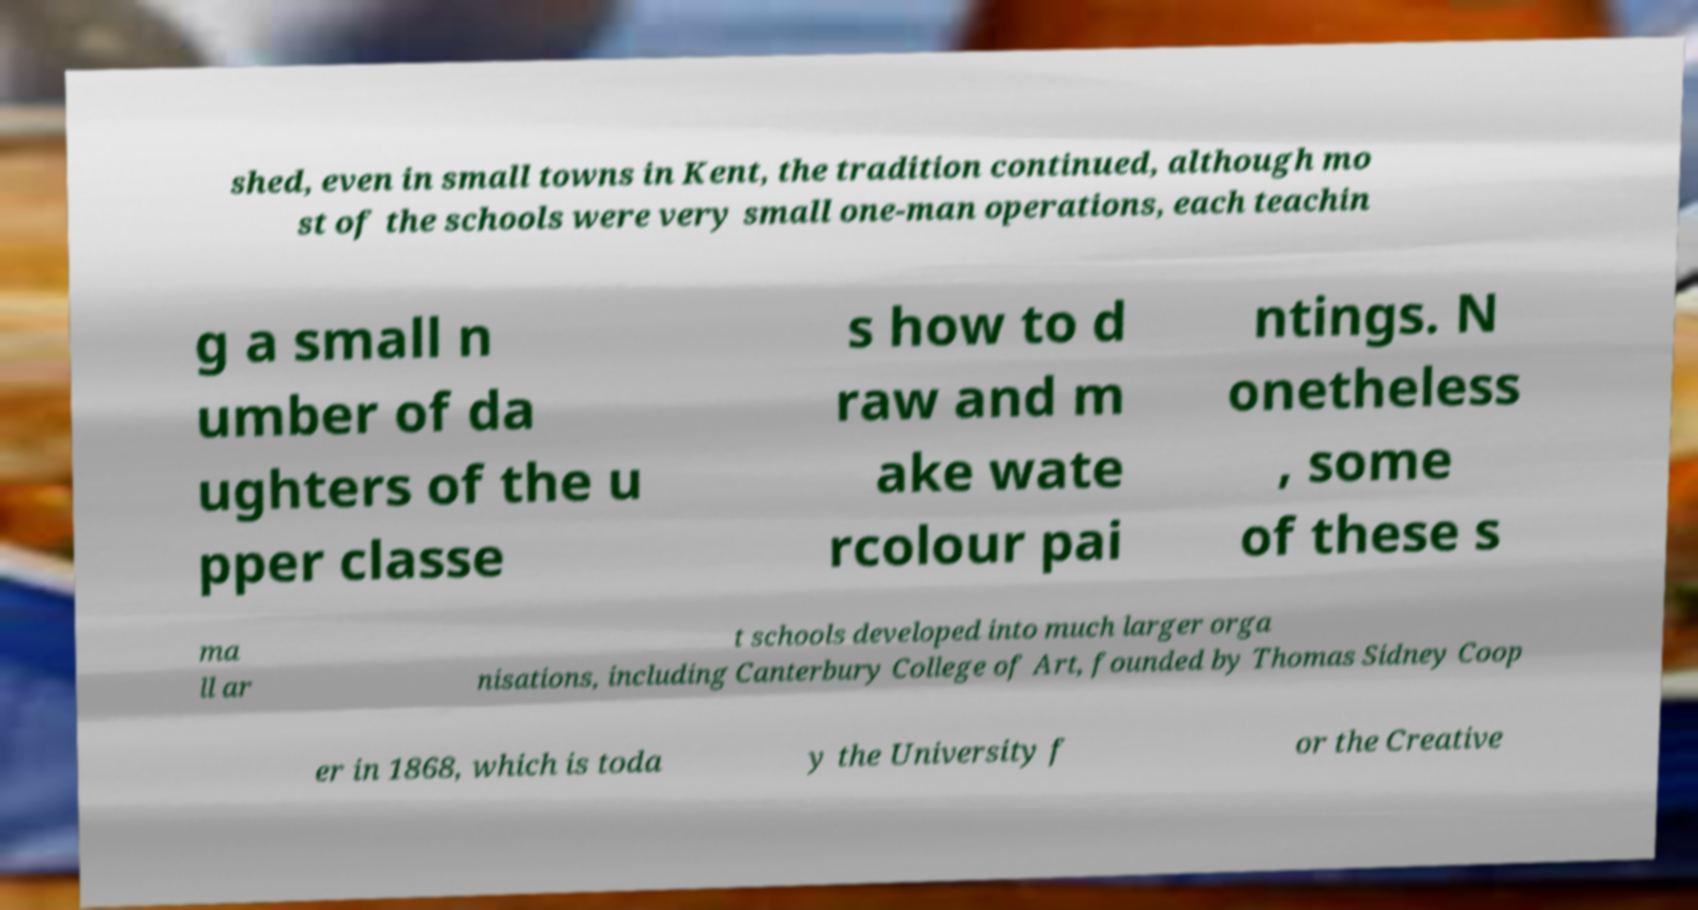For documentation purposes, I need the text within this image transcribed. Could you provide that? shed, even in small towns in Kent, the tradition continued, although mo st of the schools were very small one-man operations, each teachin g a small n umber of da ughters of the u pper classe s how to d raw and m ake wate rcolour pai ntings. N onetheless , some of these s ma ll ar t schools developed into much larger orga nisations, including Canterbury College of Art, founded by Thomas Sidney Coop er in 1868, which is toda y the University f or the Creative 